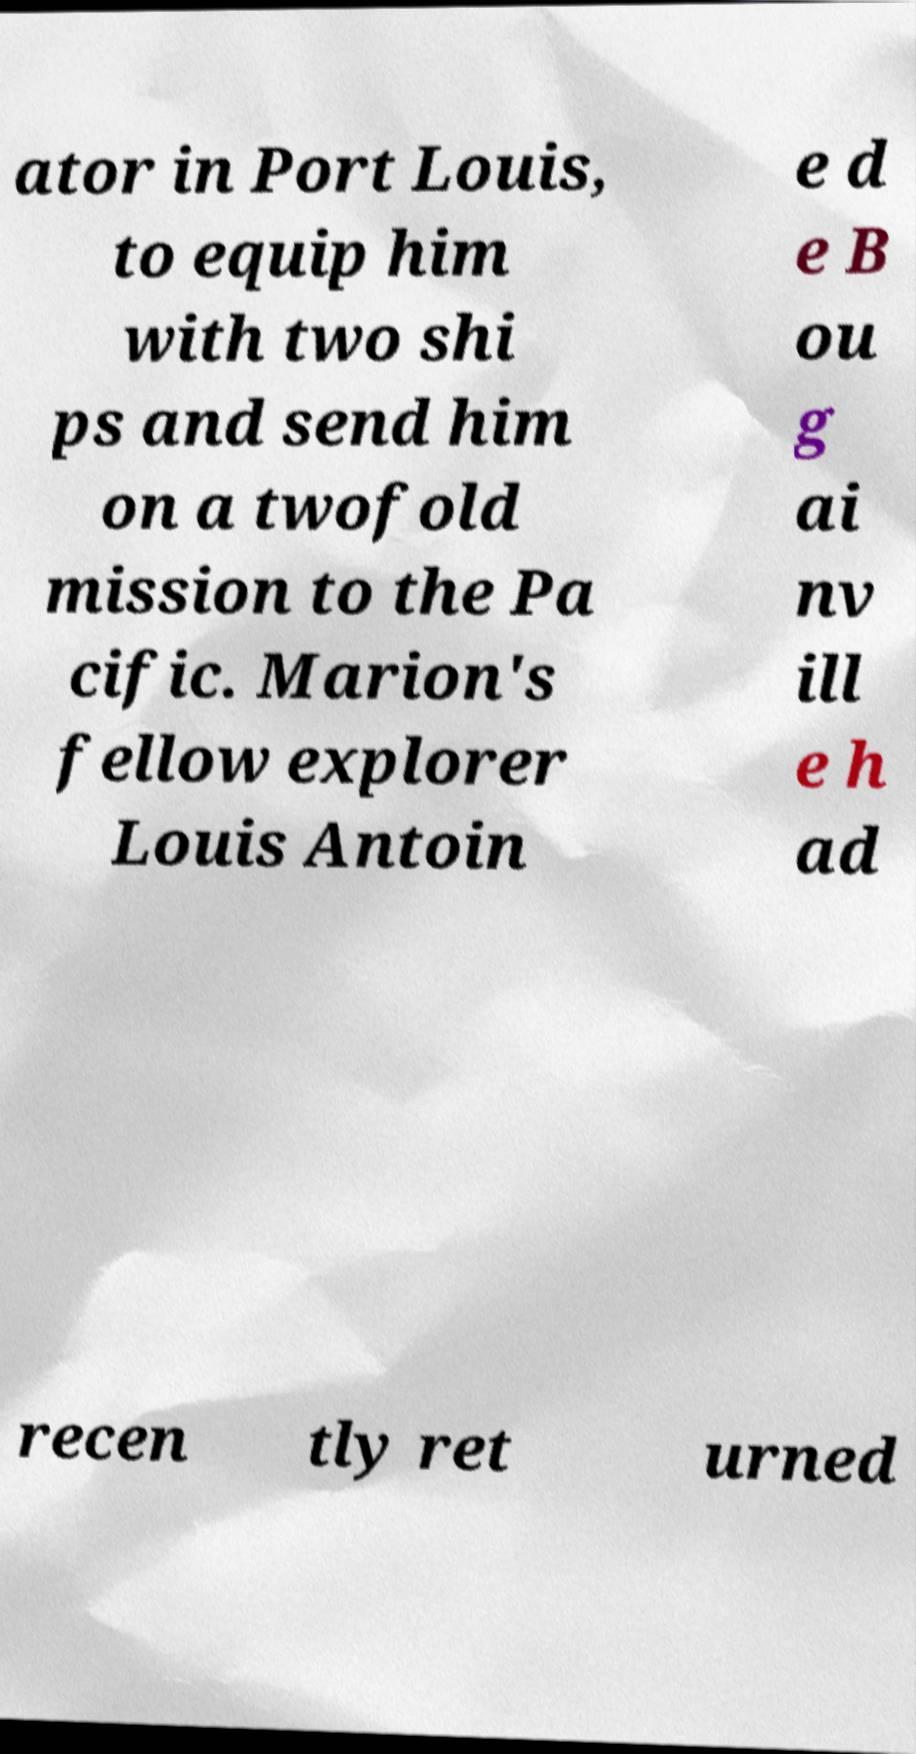What messages or text are displayed in this image? I need them in a readable, typed format. ator in Port Louis, to equip him with two shi ps and send him on a twofold mission to the Pa cific. Marion's fellow explorer Louis Antoin e d e B ou g ai nv ill e h ad recen tly ret urned 